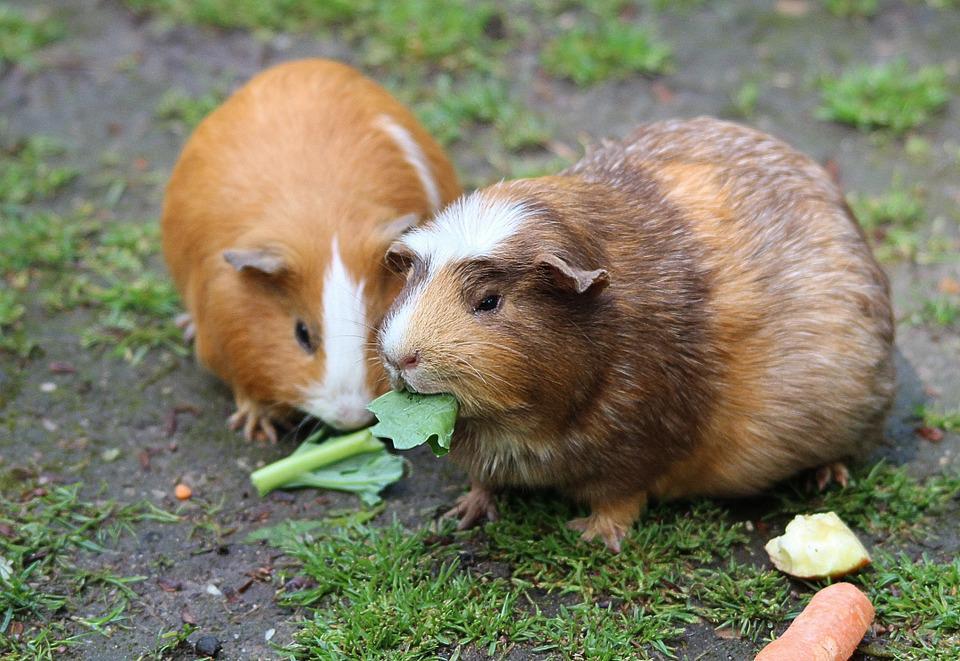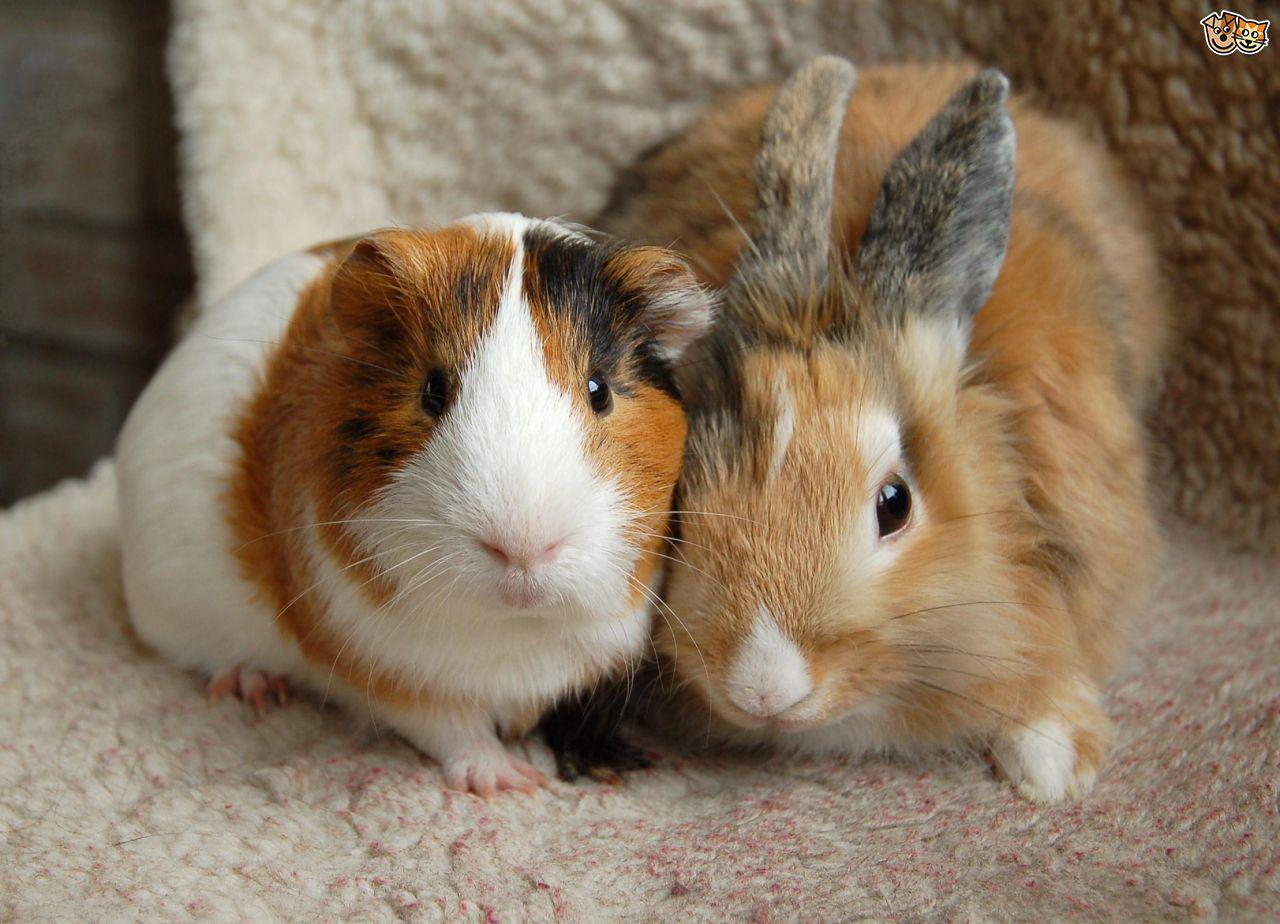The first image is the image on the left, the second image is the image on the right. Considering the images on both sides, is "There is no more than one rodent in the left image." valid? Answer yes or no. No. 